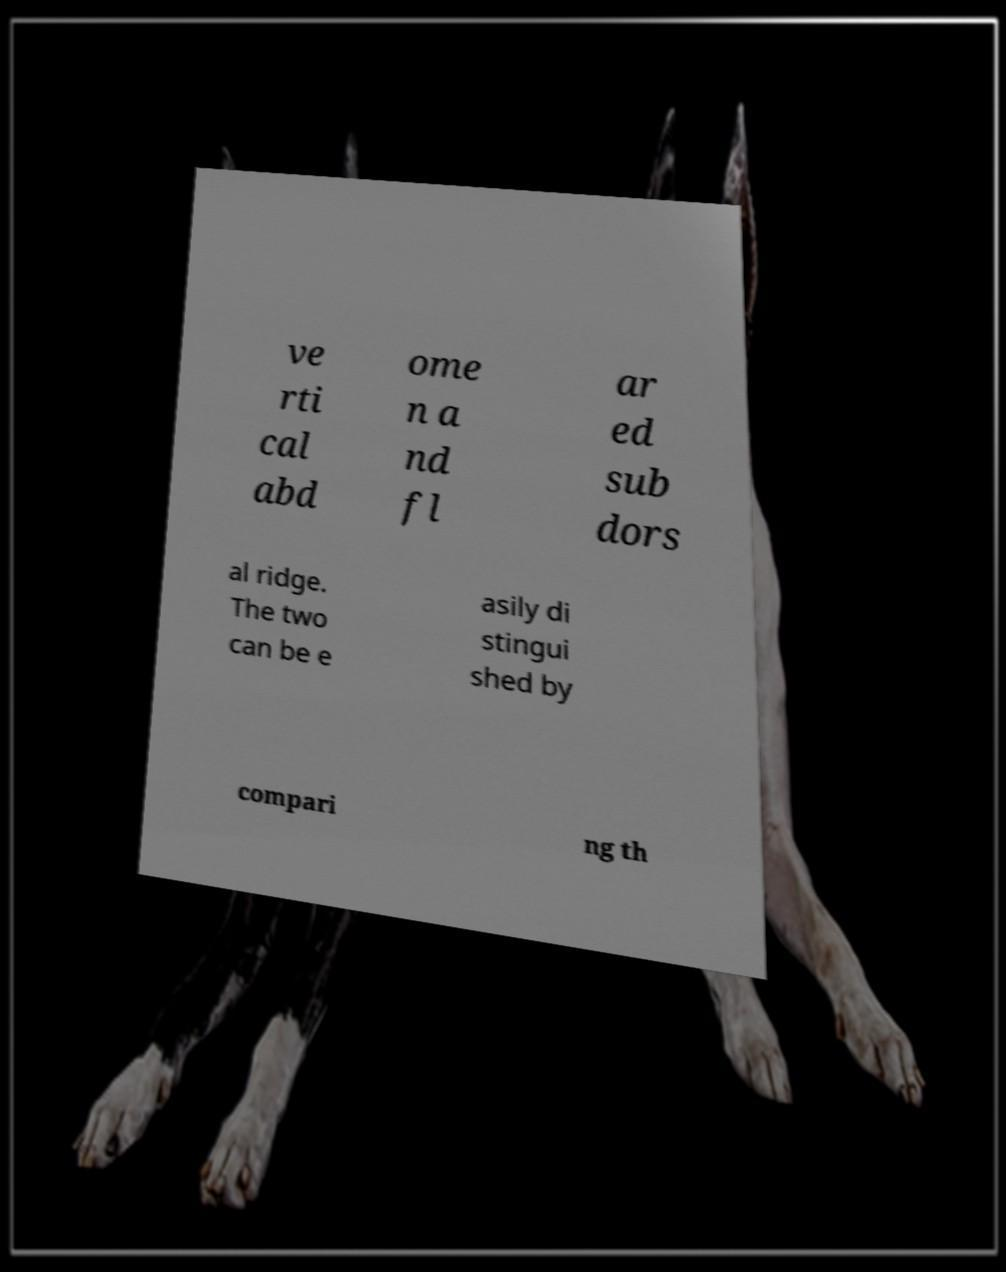Please identify and transcribe the text found in this image. ve rti cal abd ome n a nd fl ar ed sub dors al ridge. The two can be e asily di stingui shed by compari ng th 